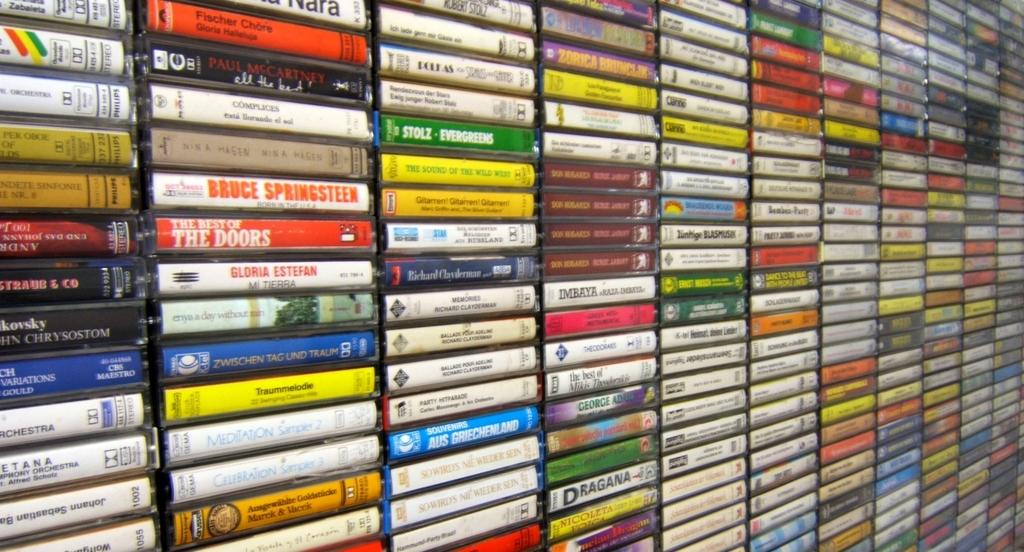<image>
Give a short and clear explanation of the subsequent image. The Best of the Doors, Gloria Estefan, and Bruce Springsteen are just a few of the many cassettes lining this wall. 